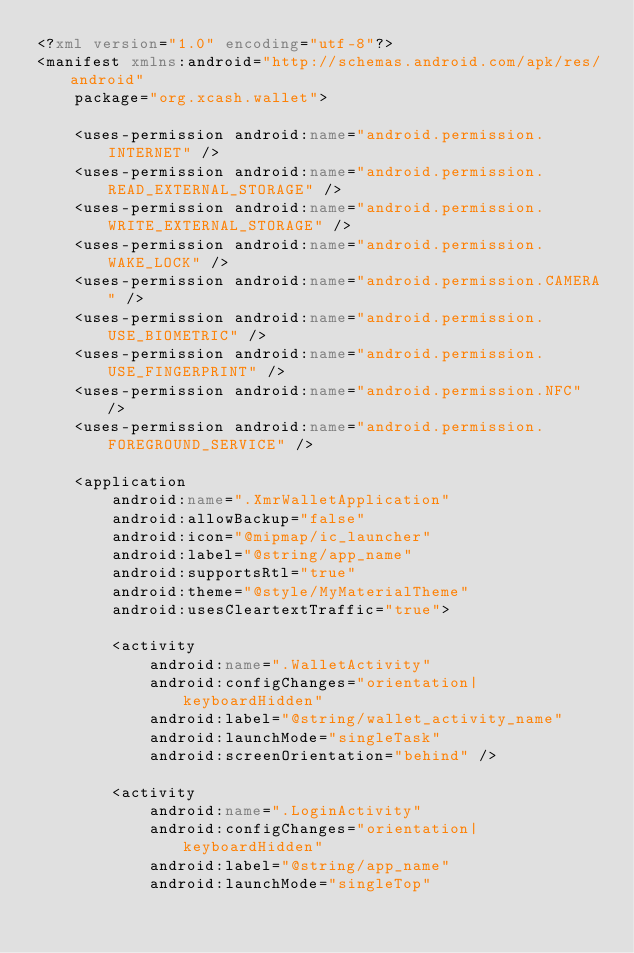Convert code to text. <code><loc_0><loc_0><loc_500><loc_500><_XML_><?xml version="1.0" encoding="utf-8"?>
<manifest xmlns:android="http://schemas.android.com/apk/res/android"
    package="org.xcash.wallet">

    <uses-permission android:name="android.permission.INTERNET" />
    <uses-permission android:name="android.permission.READ_EXTERNAL_STORAGE" />
    <uses-permission android:name="android.permission.WRITE_EXTERNAL_STORAGE" />
    <uses-permission android:name="android.permission.WAKE_LOCK" />
    <uses-permission android:name="android.permission.CAMERA" />
    <uses-permission android:name="android.permission.USE_BIOMETRIC" />
    <uses-permission android:name="android.permission.USE_FINGERPRINT" />
    <uses-permission android:name="android.permission.NFC" />
    <uses-permission android:name="android.permission.FOREGROUND_SERVICE" />

    <application
        android:name=".XmrWalletApplication"
        android:allowBackup="false"
        android:icon="@mipmap/ic_launcher"
        android:label="@string/app_name"
        android:supportsRtl="true"
        android:theme="@style/MyMaterialTheme"
        android:usesCleartextTraffic="true">

        <activity
            android:name=".WalletActivity"
            android:configChanges="orientation|keyboardHidden"
            android:label="@string/wallet_activity_name"
            android:launchMode="singleTask"
            android:screenOrientation="behind" />

        <activity
            android:name=".LoginActivity"
            android:configChanges="orientation|keyboardHidden"
            android:label="@string/app_name"
            android:launchMode="singleTop"</code> 